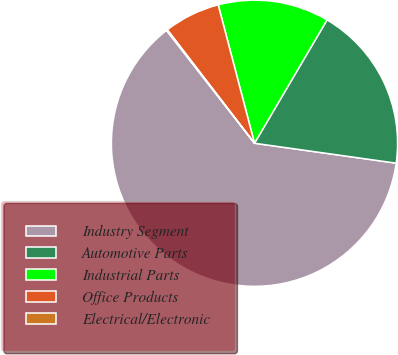Convert chart. <chart><loc_0><loc_0><loc_500><loc_500><pie_chart><fcel>Industry Segment<fcel>Automotive Parts<fcel>Industrial Parts<fcel>Office Products<fcel>Electrical/Electronic<nl><fcel>62.24%<fcel>18.76%<fcel>12.55%<fcel>6.34%<fcel>0.12%<nl></chart> 